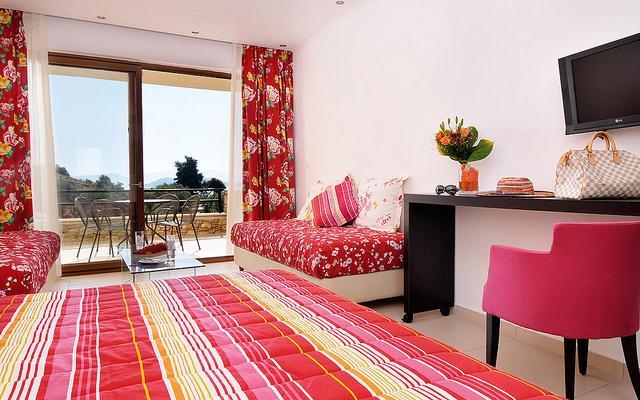Is this someone's home?
Give a very brief answer. Yes. Where is the table and chairs?
Quick response, please. Bedroom. Is it day time outside?
Answer briefly. Yes. Is there a light on the wall?
Keep it brief. No. 